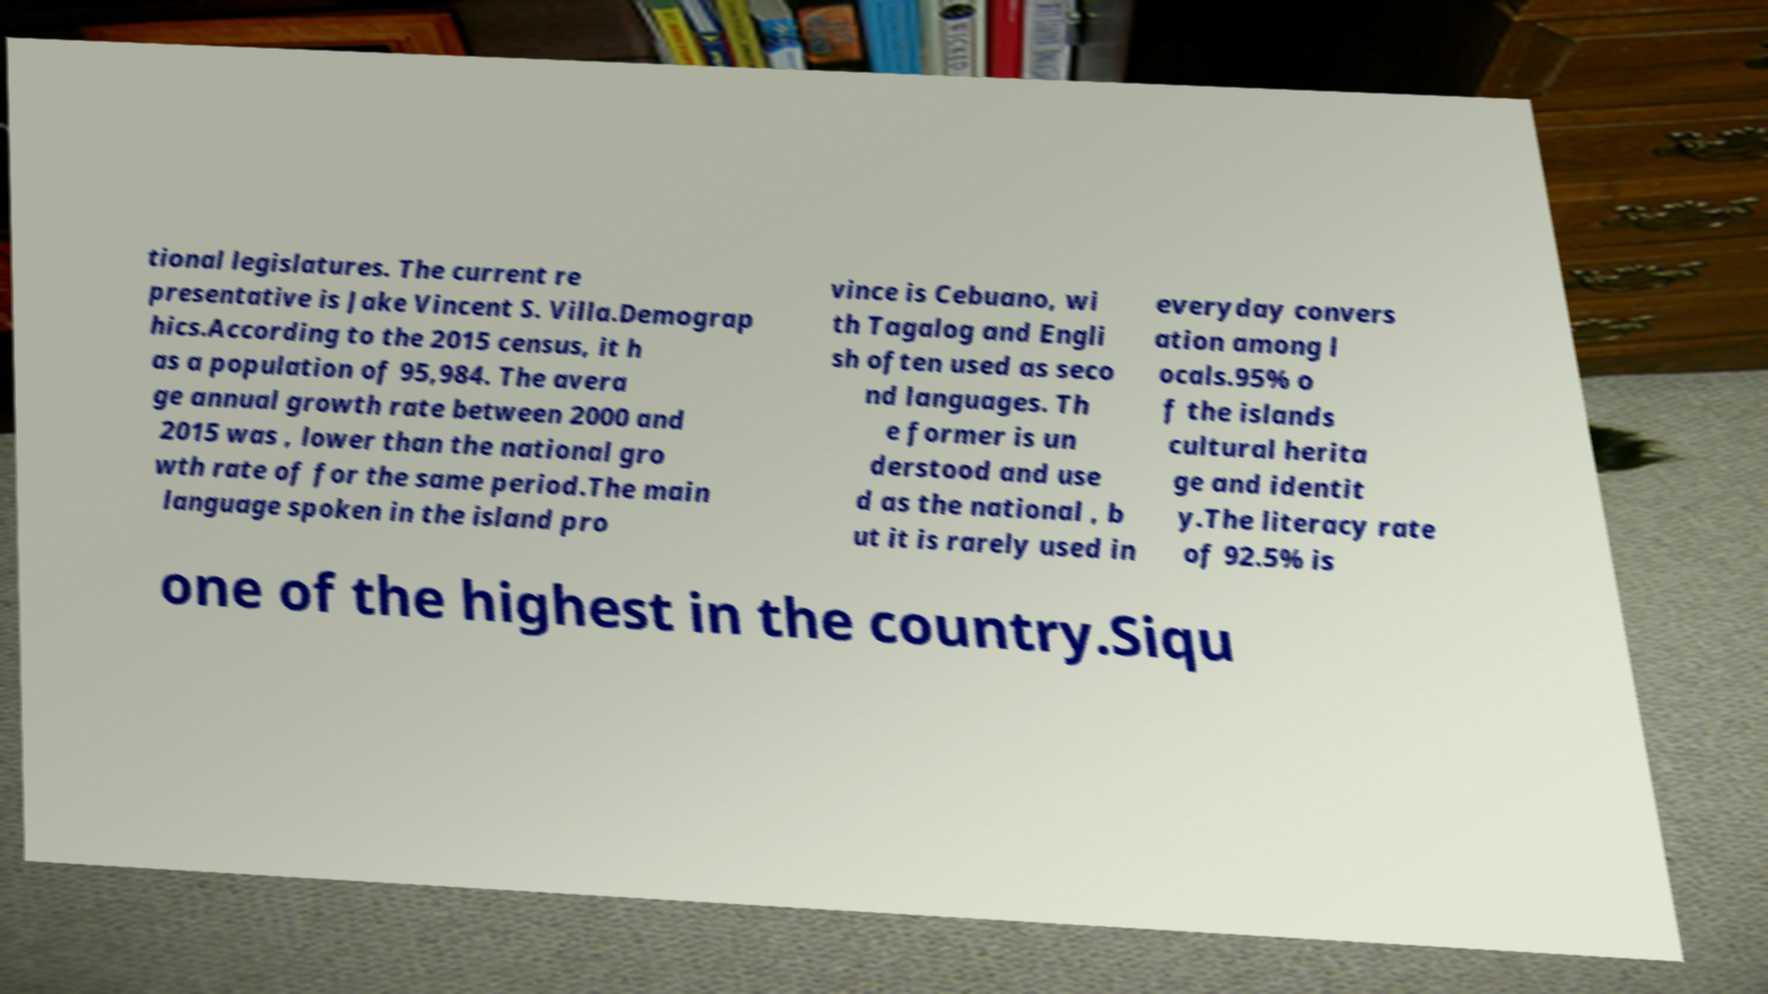Please identify and transcribe the text found in this image. tional legislatures. The current re presentative is Jake Vincent S. Villa.Demograp hics.According to the 2015 census, it h as a population of 95,984. The avera ge annual growth rate between 2000 and 2015 was , lower than the national gro wth rate of for the same period.The main language spoken in the island pro vince is Cebuano, wi th Tagalog and Engli sh often used as seco nd languages. Th e former is un derstood and use d as the national , b ut it is rarely used in everyday convers ation among l ocals.95% o f the islands cultural herita ge and identit y.The literacy rate of 92.5% is one of the highest in the country.Siqu 